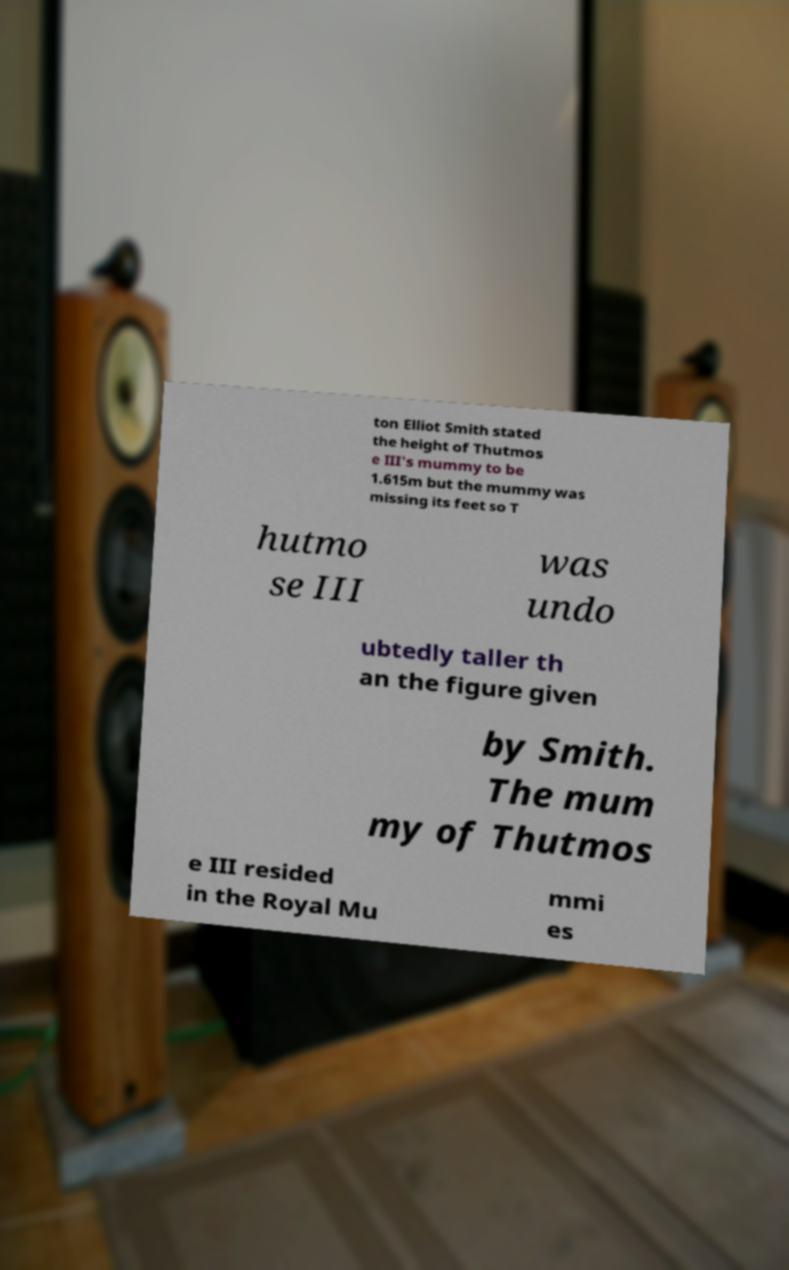Please read and relay the text visible in this image. What does it say? ton Elliot Smith stated the height of Thutmos e III's mummy to be 1.615m but the mummy was missing its feet so T hutmo se III was undo ubtedly taller th an the figure given by Smith. The mum my of Thutmos e III resided in the Royal Mu mmi es 